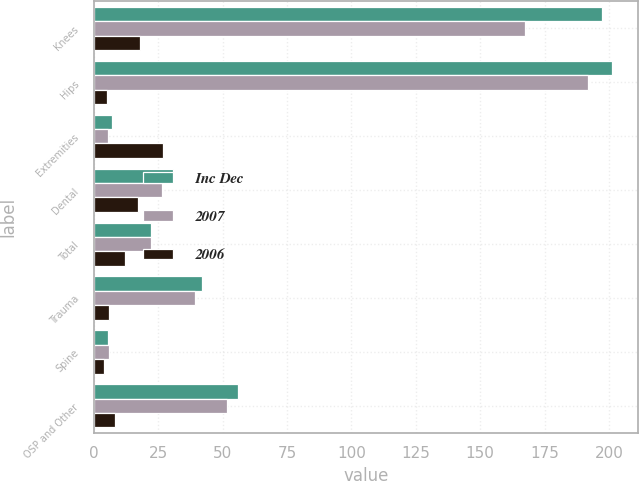<chart> <loc_0><loc_0><loc_500><loc_500><stacked_bar_chart><ecel><fcel>Knees<fcel>Hips<fcel>Extremities<fcel>Dental<fcel>Total<fcel>Trauma<fcel>Spine<fcel>OSP and Other<nl><fcel>Inc Dec<fcel>197.2<fcel>201.2<fcel>6.9<fcel>30.8<fcel>22.2<fcel>41.8<fcel>5.5<fcel>56.1<nl><fcel>2007<fcel>167.5<fcel>191.7<fcel>5.5<fcel>26.4<fcel>22.2<fcel>39.4<fcel>5.7<fcel>51.6<nl><fcel>2006<fcel>18<fcel>5<fcel>27<fcel>17<fcel>12<fcel>6<fcel>4<fcel>8<nl></chart> 